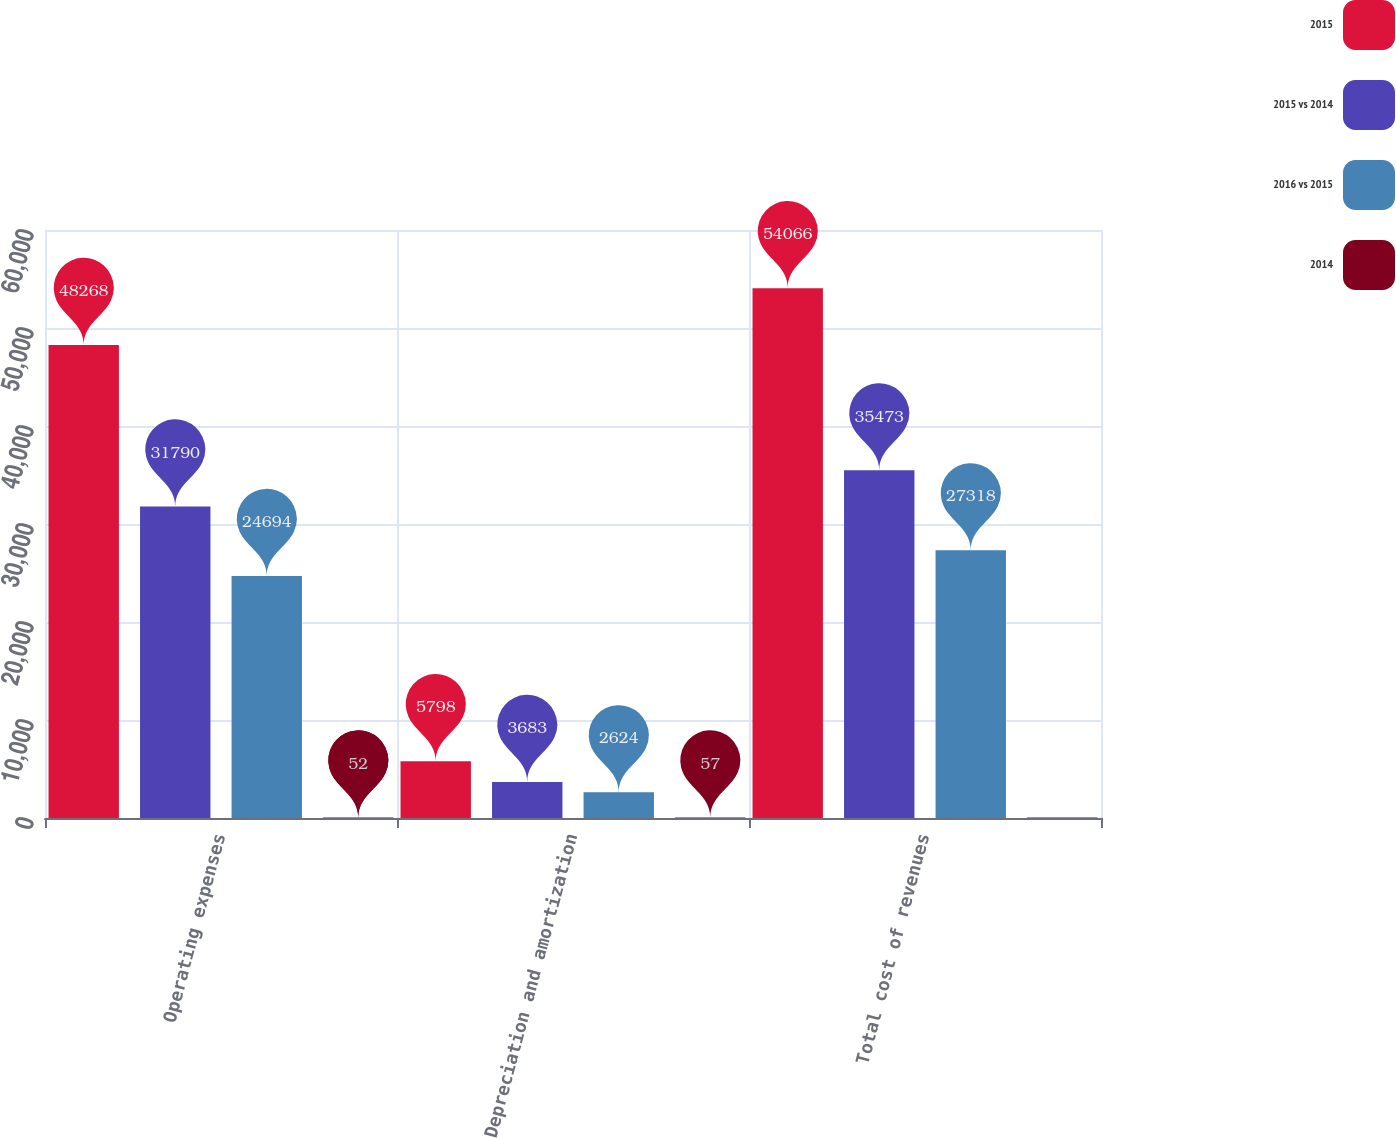Convert chart to OTSL. <chart><loc_0><loc_0><loc_500><loc_500><stacked_bar_chart><ecel><fcel>Operating expenses<fcel>Depreciation and amortization<fcel>Total cost of revenues<nl><fcel>2015<fcel>48268<fcel>5798<fcel>54066<nl><fcel>2015 vs 2014<fcel>31790<fcel>3683<fcel>35473<nl><fcel>2016 vs 2015<fcel>24694<fcel>2624<fcel>27318<nl><fcel>2014<fcel>52<fcel>57<fcel>52<nl></chart> 